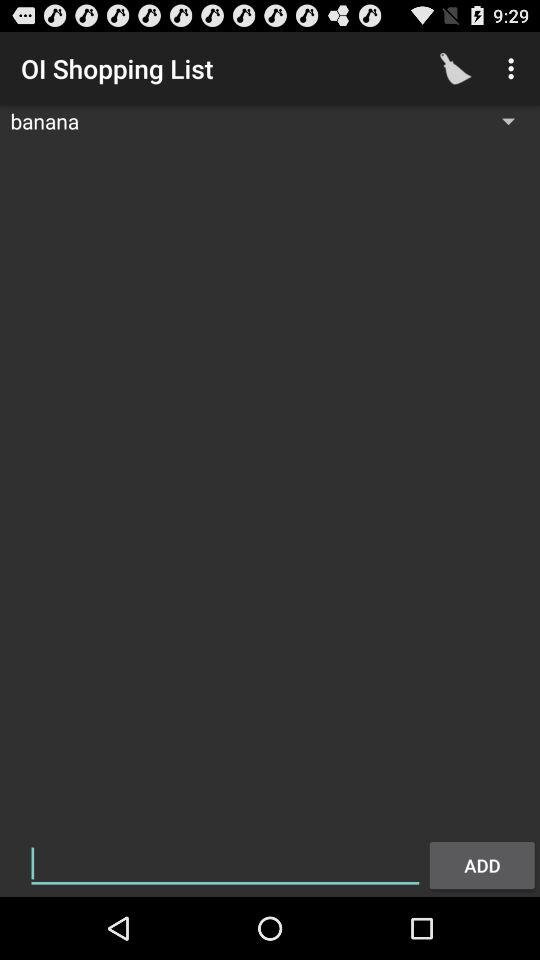What item is in the shopping list? The item in the shopping list is "banana". 